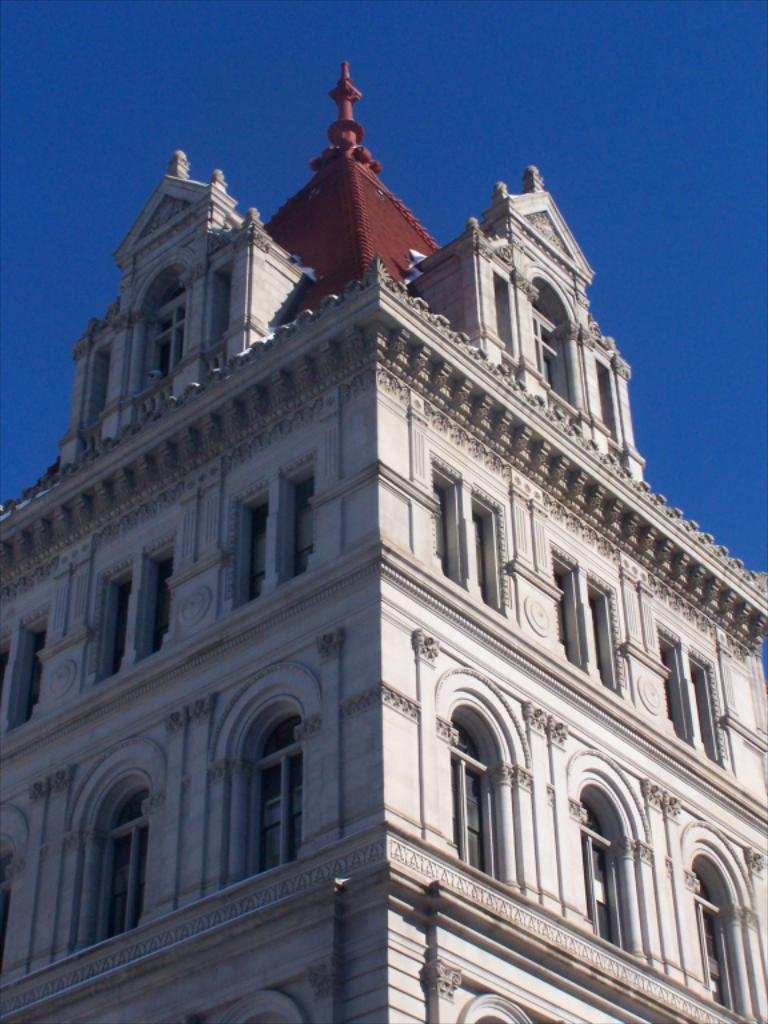What is the main structure in the image? There is a building in the image. What feature can be seen on the building? The building has windows. What else is visible in the image besides the building? The sky is visible in the image. Can you see a cat walking on the sidewalk in the image? There is no cat or sidewalk present in the image; it only features a building and the sky. 